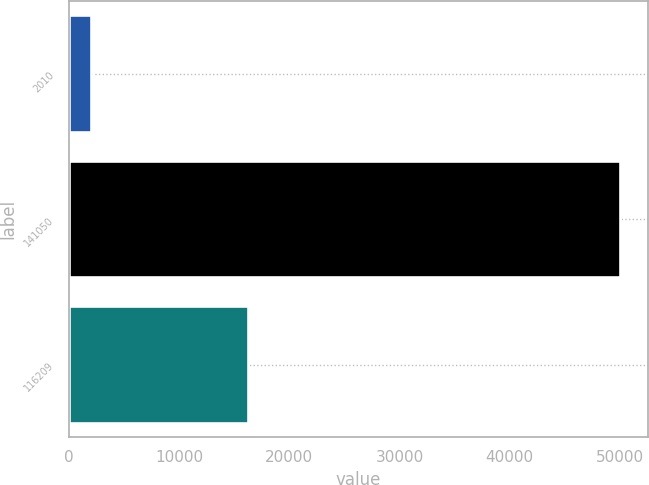Convert chart to OTSL. <chart><loc_0><loc_0><loc_500><loc_500><bar_chart><fcel>2010<fcel>141050<fcel>116209<nl><fcel>2009<fcel>50000<fcel>16209<nl></chart> 